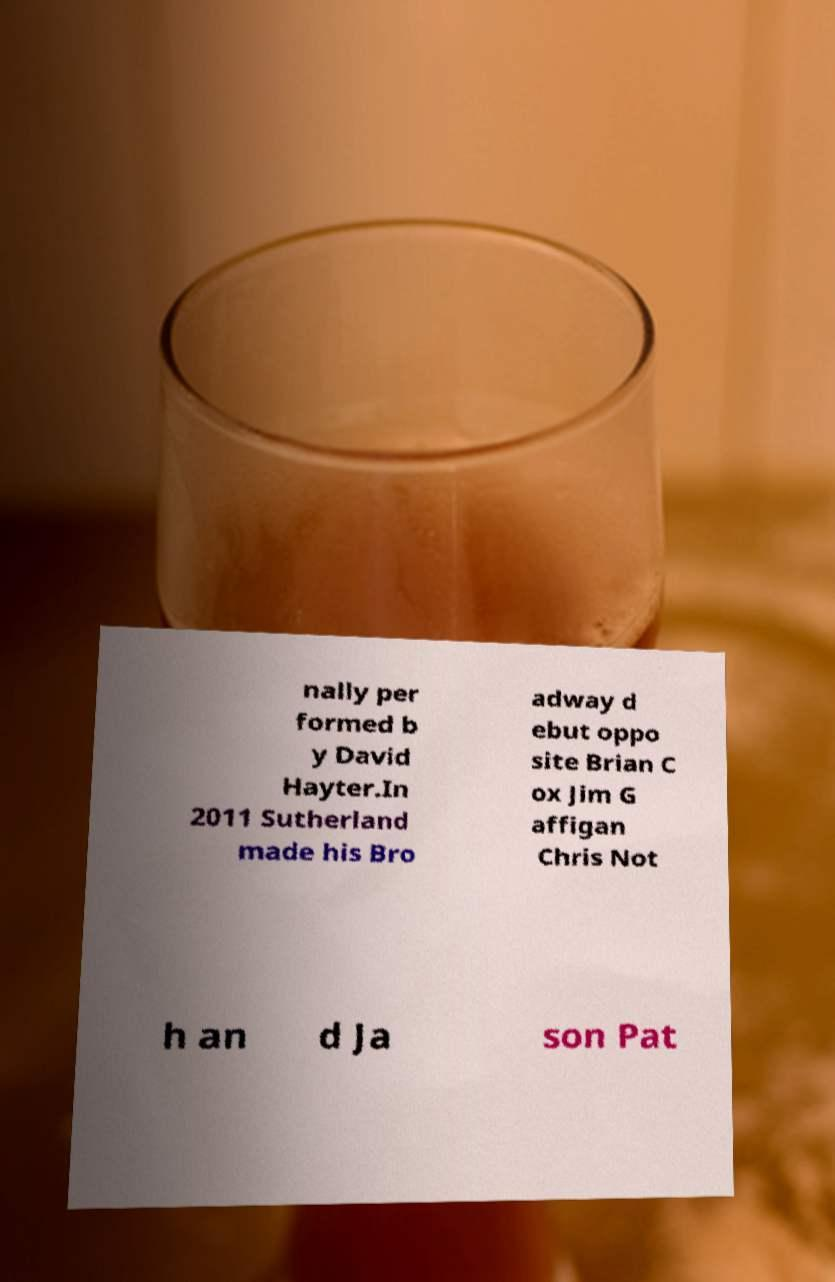Please read and relay the text visible in this image. What does it say? nally per formed b y David Hayter.In 2011 Sutherland made his Bro adway d ebut oppo site Brian C ox Jim G affigan Chris Not h an d Ja son Pat 